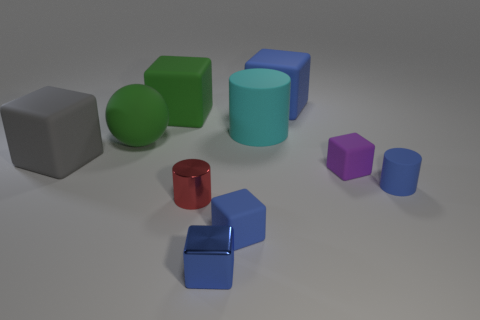Is the color of the small shiny block the same as the tiny matte cylinder?
Give a very brief answer. Yes. Is the number of large rubber spheres less than the number of tiny cylinders?
Provide a succinct answer. Yes. How many other things are the same color as the rubber sphere?
Give a very brief answer. 1. How many tiny gray rubber cubes are there?
Your answer should be very brief. 0. Is the number of green spheres that are on the left side of the rubber sphere less than the number of gray balls?
Ensure brevity in your answer.  No. Do the cylinder that is behind the big gray object and the purple object have the same material?
Your answer should be very brief. Yes. There is a cyan thing that is on the left side of the cylinder that is to the right of the cylinder behind the big gray rubber block; what is its shape?
Your response must be concise. Cylinder. Are there any cylinders of the same size as the purple rubber block?
Provide a short and direct response. Yes. What is the size of the red cylinder?
Make the answer very short. Small. How many other shiny cylinders have the same size as the red cylinder?
Your answer should be very brief. 0. 